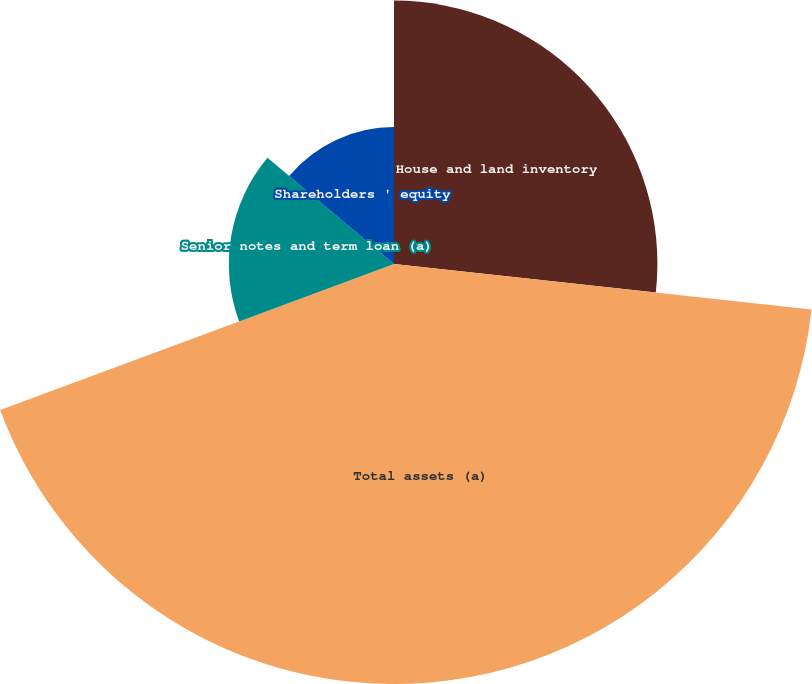<chart> <loc_0><loc_0><loc_500><loc_500><pie_chart><fcel>House and land inventory<fcel>Total assets (a)<fcel>Senior notes and term loan (a)<fcel>Shareholders ' equity<nl><fcel>26.73%<fcel>42.62%<fcel>16.76%<fcel>13.89%<nl></chart> 